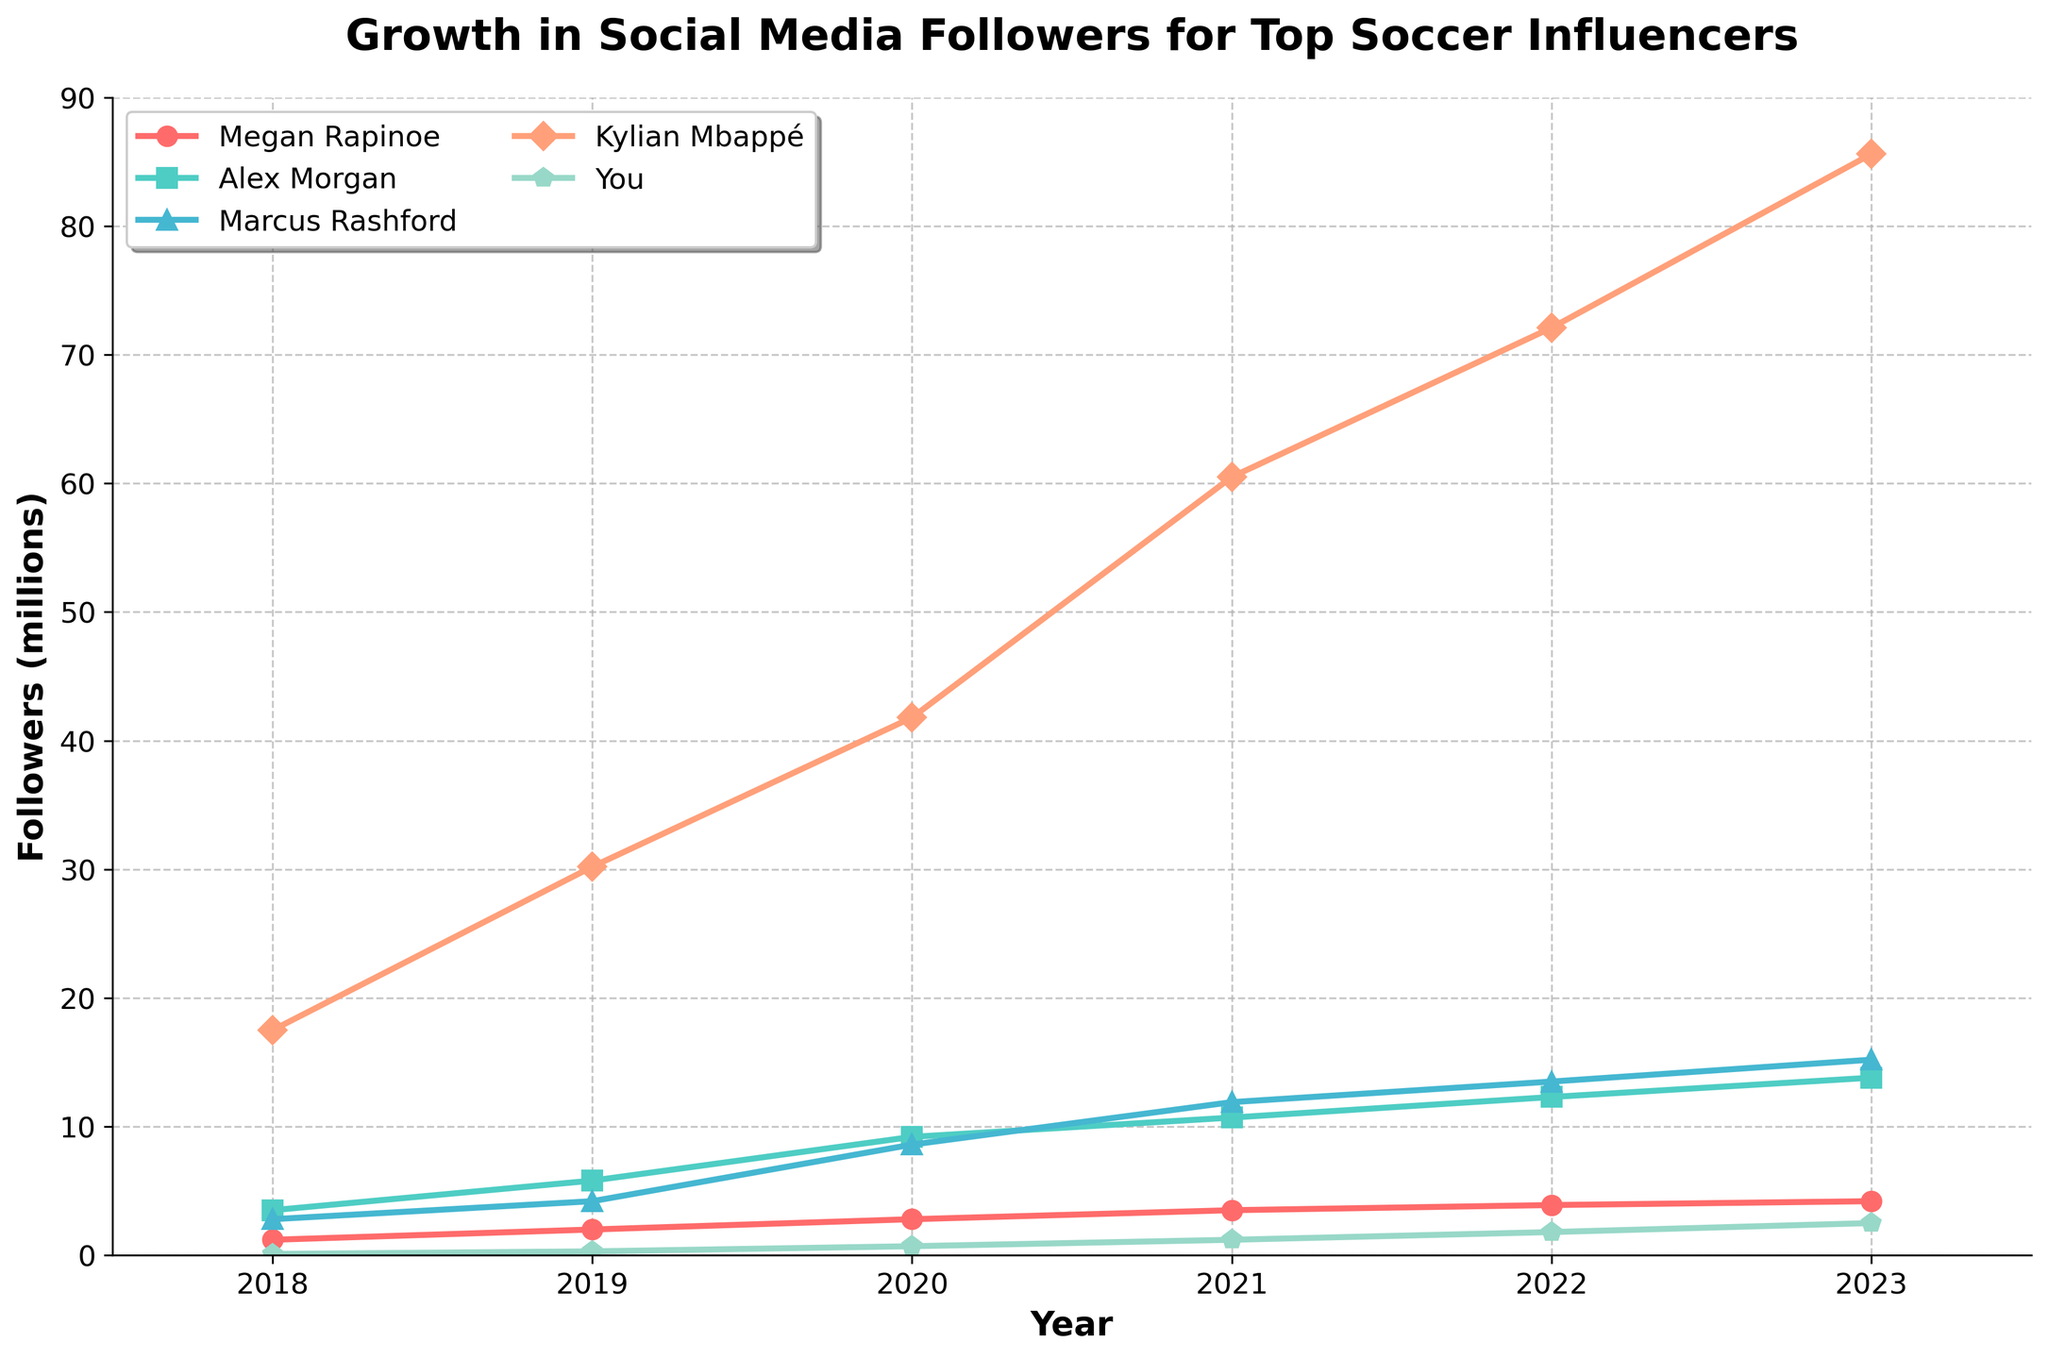What's the trend in followers for Megan Rapinoe from 2018 to 2023? To identify the trend, look at Megan Rapinoe's follower count from 2018 to 2023 on the y-axis. From 2018 (1.2 million), it steadily rises to 2023 (4.2 million). This indicates a consistent growth over these years.
Answer: Steady growth Which influencer had the highest followers in 2023? To find the influencer with the highest followers in 2023, look at the values on the y-axis for all influencers for the year 2023. Kylian Mbappé’s followers (85.6 million) are the highest.
Answer: Kylian Mbappé How many million more followers does Kylian Mbappé have than Megan Rapinoe in 2023? Subtract Megan Rapinoe's 2023 followers (4.2 million) from Kylian Mbappé's 2023 followers (85.6 million). 85.6 - 4.2 = 81.4 million.
Answer: 81.4 million Who showed the most significant growth in followers from 2018 to 2023? Calculate the growth for each influencer by subtracting their 2018 followers from their 2023 followers. Compare these values:
Kylian Mbappé: (85.6 - 17.5) = 68.1
Megan Rapinoe: (4.2 - 1.2) = 3
Alex Morgan: (13.8 - 3.5) = 10.3
Marcus Rashford: (15.2 - 2.8) = 12.4
You: (2.5 - 0.1) = 2.4
Kylian Mbappé has the highest growth of 68.1 million.
Answer: Kylian Mbappé Between 2019 and 2020, which influencer gained the most followers? Calculate the difference in followers for each influencer from 2019 to 2020:
Megan Rapinoe: (2.8 - 2.0) = 0.8 million
Alex Morgan: (9.2 - 5.8) = 3.4 million
Marcus Rashford: (8.6 - 4.2) = 4.4 million
Kylian Mbappé: (41.8 - 30.2) = 11.6 million
You: (0.7 - 0.3) = 0.4 million
Kylian Mbappé gained the most with 11.6 million followers.
Answer: Kylian Mbappé What is the average number of followers for Alex Morgan from 2018 to 2023? Sum the follower counts for Alex Morgan from 2018 to 2023 and then divide by the number of years (6): (3.5 + 5.8 + 9.2 + 10.7 + 12.3 + 13.8) / 6 = 55.3 / 6 ≈ 9.22 million.
Answer: 9.22 million Who had a higher number of followers in 2020, You or Megan Rapinoe? Compare the followers in 2020 for both: Megan Rapinoe (2.8 million) and You (0.7 million). Megan Rapinoe had more.
Answer: Megan Rapinoe What percentage increase did Marcus Rashford experience from 2018 to 2023? Calculate the percentage increase using the formula: [(final value - initial value) / initial value] * 100. For Marcus Rashford: [(15.2 - 2.8) / 2.8] * 100 ≈ 442.86%.
Answer: 442.86% Which influencer had the smallest growth in followers between 2019 and 2020? Calculate the growth for each influencer from 2019 to 2020:
Megan Rapinoe: (2.8 - 2.0) = 0.8 million
Alex Morgan: (9.2 - 5.8) = 3.4 million
Marcus Rashford: (8.6 - 4.2) = 4.4 million
Kylian Mbappé: (41.8 - 30.2) = 11.6 million
You: (0.7 - 0.3) = 0.4 million
Your growth of 0.4 million is the smallest.
Answer: You Compare the trends in follower growth between Alex Morgan and Marcus Rashford between 2018 and 2023. Observe the line trends for Alex Morgan and Marcus Rashford. Both exhibit an upward trend, but Alex Morgan's line initially rises more slowly before increasing faster after 2019, whereas Marcus Rashford shows a more consistent steady rise throughout the period.
Answer: Both have upward trends; Alex Morgan's rises faster post-2019, while Marcus Rashford's is consistently steady 